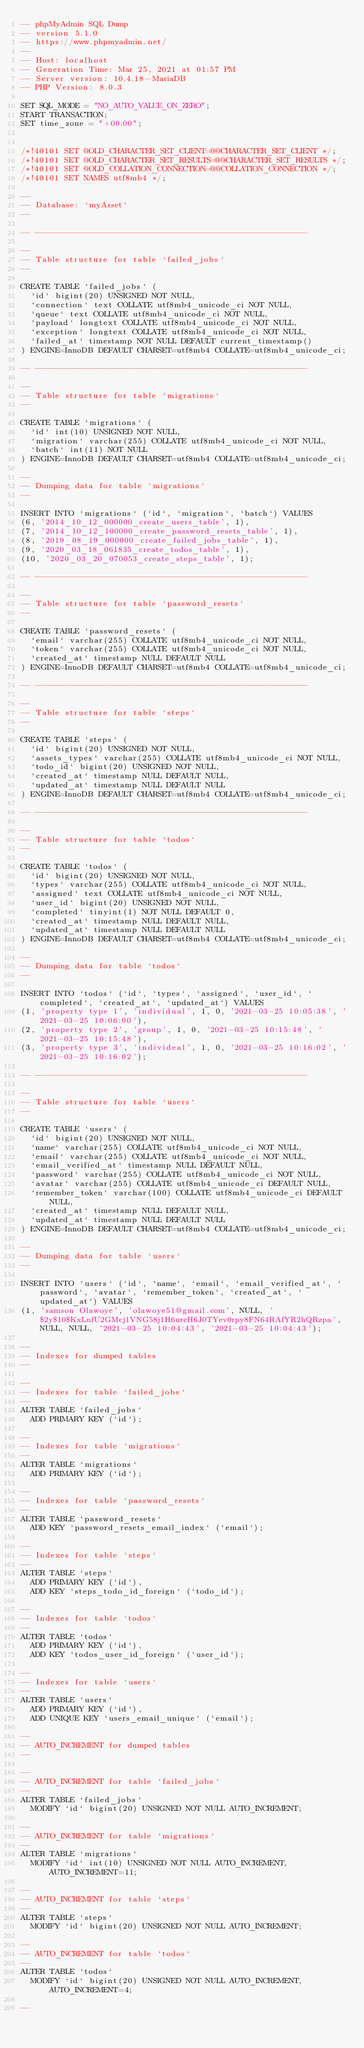<code> <loc_0><loc_0><loc_500><loc_500><_SQL_>-- phpMyAdmin SQL Dump
-- version 5.1.0
-- https://www.phpmyadmin.net/
--
-- Host: localhost
-- Generation Time: Mar 25, 2021 at 01:57 PM
-- Server version: 10.4.18-MariaDB
-- PHP Version: 8.0.3

SET SQL_MODE = "NO_AUTO_VALUE_ON_ZERO";
START TRANSACTION;
SET time_zone = "+00:00";


/*!40101 SET @OLD_CHARACTER_SET_CLIENT=@@CHARACTER_SET_CLIENT */;
/*!40101 SET @OLD_CHARACTER_SET_RESULTS=@@CHARACTER_SET_RESULTS */;
/*!40101 SET @OLD_COLLATION_CONNECTION=@@COLLATION_CONNECTION */;
/*!40101 SET NAMES utf8mb4 */;

--
-- Database: `myAsset`
--

-- --------------------------------------------------------

--
-- Table structure for table `failed_jobs`
--

CREATE TABLE `failed_jobs` (
  `id` bigint(20) UNSIGNED NOT NULL,
  `connection` text COLLATE utf8mb4_unicode_ci NOT NULL,
  `queue` text COLLATE utf8mb4_unicode_ci NOT NULL,
  `payload` longtext COLLATE utf8mb4_unicode_ci NOT NULL,
  `exception` longtext COLLATE utf8mb4_unicode_ci NOT NULL,
  `failed_at` timestamp NOT NULL DEFAULT current_timestamp()
) ENGINE=InnoDB DEFAULT CHARSET=utf8mb4 COLLATE=utf8mb4_unicode_ci;

-- --------------------------------------------------------

--
-- Table structure for table `migrations`
--

CREATE TABLE `migrations` (
  `id` int(10) UNSIGNED NOT NULL,
  `migration` varchar(255) COLLATE utf8mb4_unicode_ci NOT NULL,
  `batch` int(11) NOT NULL
) ENGINE=InnoDB DEFAULT CHARSET=utf8mb4 COLLATE=utf8mb4_unicode_ci;

--
-- Dumping data for table `migrations`
--

INSERT INTO `migrations` (`id`, `migration`, `batch`) VALUES
(6, '2014_10_12_000000_create_users_table', 1),
(7, '2014_10_12_100000_create_password_resets_table', 1),
(8, '2019_08_19_000000_create_failed_jobs_table', 1),
(9, '2020_03_18_061835_create_todos_table', 1),
(10, '2020_03_20_070053_create_steps_table', 1);

-- --------------------------------------------------------

--
-- Table structure for table `password_resets`
--

CREATE TABLE `password_resets` (
  `email` varchar(255) COLLATE utf8mb4_unicode_ci NOT NULL,
  `token` varchar(255) COLLATE utf8mb4_unicode_ci NOT NULL,
  `created_at` timestamp NULL DEFAULT NULL
) ENGINE=InnoDB DEFAULT CHARSET=utf8mb4 COLLATE=utf8mb4_unicode_ci;

-- --------------------------------------------------------

--
-- Table structure for table `steps`
--

CREATE TABLE `steps` (
  `id` bigint(20) UNSIGNED NOT NULL,
  `assets_types` varchar(255) COLLATE utf8mb4_unicode_ci NOT NULL,
  `todo_id` bigint(20) UNSIGNED NOT NULL,
  `created_at` timestamp NULL DEFAULT NULL,
  `updated_at` timestamp NULL DEFAULT NULL
) ENGINE=InnoDB DEFAULT CHARSET=utf8mb4 COLLATE=utf8mb4_unicode_ci;

-- --------------------------------------------------------

--
-- Table structure for table `todos`
--

CREATE TABLE `todos` (
  `id` bigint(20) UNSIGNED NOT NULL,
  `types` varchar(255) COLLATE utf8mb4_unicode_ci NOT NULL,
  `assigned` text COLLATE utf8mb4_unicode_ci NOT NULL,
  `user_id` bigint(20) UNSIGNED NOT NULL,
  `completed` tinyint(1) NOT NULL DEFAULT 0,
  `created_at` timestamp NULL DEFAULT NULL,
  `updated_at` timestamp NULL DEFAULT NULL
) ENGINE=InnoDB DEFAULT CHARSET=utf8mb4 COLLATE=utf8mb4_unicode_ci;

--
-- Dumping data for table `todos`
--

INSERT INTO `todos` (`id`, `types`, `assigned`, `user_id`, `completed`, `created_at`, `updated_at`) VALUES
(1, 'property type 1', 'individual', 1, 0, '2021-03-25 10:05:38', '2021-03-25 10:06:00'),
(2, 'property type 2', 'group', 1, 0, '2021-03-25 10:15:48', '2021-03-25 10:15:48'),
(3, 'property type 3', 'individeal', 1, 0, '2021-03-25 10:16:02', '2021-03-25 10:16:02');

-- --------------------------------------------------------

--
-- Table structure for table `users`
--

CREATE TABLE `users` (
  `id` bigint(20) UNSIGNED NOT NULL,
  `name` varchar(255) COLLATE utf8mb4_unicode_ci NOT NULL,
  `email` varchar(255) COLLATE utf8mb4_unicode_ci NOT NULL,
  `email_verified_at` timestamp NULL DEFAULT NULL,
  `password` varchar(255) COLLATE utf8mb4_unicode_ci NOT NULL,
  `avatar` varchar(255) COLLATE utf8mb4_unicode_ci DEFAULT NULL,
  `remember_token` varchar(100) COLLATE utf8mb4_unicode_ci DEFAULT NULL,
  `created_at` timestamp NULL DEFAULT NULL,
  `updated_at` timestamp NULL DEFAULT NULL
) ENGINE=InnoDB DEFAULT CHARSET=utf8mb4 COLLATE=utf8mb4_unicode_ci;

--
-- Dumping data for table `users`
--

INSERT INTO `users` (`id`, `name`, `email`, `email_verified_at`, `password`, `avatar`, `remember_token`, `created_at`, `updated_at`) VALUES
(1, 'samson Olawoye', 'olawoye51@gmail.com', NULL, '$2y$10$KxLnfU2GMcj1VNG58j1H6ureH6J0TYev0rpy8FN64RAfYR2hQRzpa', NULL, NULL, '2021-03-25 10:04:43', '2021-03-25 10:04:43');

--
-- Indexes for dumped tables
--

--
-- Indexes for table `failed_jobs`
--
ALTER TABLE `failed_jobs`
  ADD PRIMARY KEY (`id`);

--
-- Indexes for table `migrations`
--
ALTER TABLE `migrations`
  ADD PRIMARY KEY (`id`);

--
-- Indexes for table `password_resets`
--
ALTER TABLE `password_resets`
  ADD KEY `password_resets_email_index` (`email`);

--
-- Indexes for table `steps`
--
ALTER TABLE `steps`
  ADD PRIMARY KEY (`id`),
  ADD KEY `steps_todo_id_foreign` (`todo_id`);

--
-- Indexes for table `todos`
--
ALTER TABLE `todos`
  ADD PRIMARY KEY (`id`),
  ADD KEY `todos_user_id_foreign` (`user_id`);

--
-- Indexes for table `users`
--
ALTER TABLE `users`
  ADD PRIMARY KEY (`id`),
  ADD UNIQUE KEY `users_email_unique` (`email`);

--
-- AUTO_INCREMENT for dumped tables
--

--
-- AUTO_INCREMENT for table `failed_jobs`
--
ALTER TABLE `failed_jobs`
  MODIFY `id` bigint(20) UNSIGNED NOT NULL AUTO_INCREMENT;

--
-- AUTO_INCREMENT for table `migrations`
--
ALTER TABLE `migrations`
  MODIFY `id` int(10) UNSIGNED NOT NULL AUTO_INCREMENT, AUTO_INCREMENT=11;

--
-- AUTO_INCREMENT for table `steps`
--
ALTER TABLE `steps`
  MODIFY `id` bigint(20) UNSIGNED NOT NULL AUTO_INCREMENT;

--
-- AUTO_INCREMENT for table `todos`
--
ALTER TABLE `todos`
  MODIFY `id` bigint(20) UNSIGNED NOT NULL AUTO_INCREMENT, AUTO_INCREMENT=4;

--</code> 